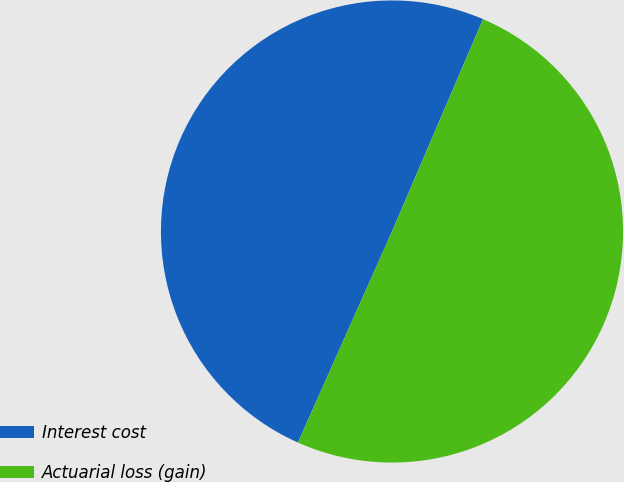Convert chart. <chart><loc_0><loc_0><loc_500><loc_500><pie_chart><fcel>Interest cost<fcel>Actuarial loss (gain)<nl><fcel>49.77%<fcel>50.23%<nl></chart> 